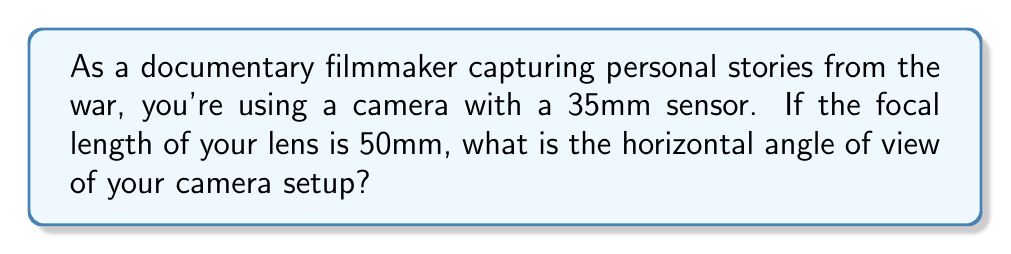Can you solve this math problem? To calculate the horizontal angle of view, we'll use the following steps:

1. The formula for the angle of view (AOV) is:

   $$AOV = 2 \arctan(\frac{d}{2f})$$

   Where:
   $d$ = sensor width
   $f$ = focal length

2. For a 35mm sensor, the horizontal width is typically 36mm.

3. Substituting our values:
   $d = 36mm$
   $f = 50mm$

4. Let's plug these into our formula:

   $$AOV = 2 \arctan(\frac{36}{2 \cdot 50})$$

5. Simplify inside the parentheses:

   $$AOV = 2 \arctan(\frac{18}{50})$$

6. Calculate the arctangent:

   $$AOV = 2 \arctan(0.36)$$
   $$AOV = 2 \cdot 19.79°$$

7. Multiply:

   $$AOV = 39.58°$$

[asy]
import geometry;

size(200);
pair O=(0,0);
draw((-2,0)--(2,0),Arrow);
draw((0,-0.5)--(0,2),Arrow);
draw(O--(-1.5,2),Arrow);
draw(O--(1.5,2),Arrow);
label("39.58°", (0.5,1), E);
dot(O);
[/asy]
Answer: $39.58°$ 